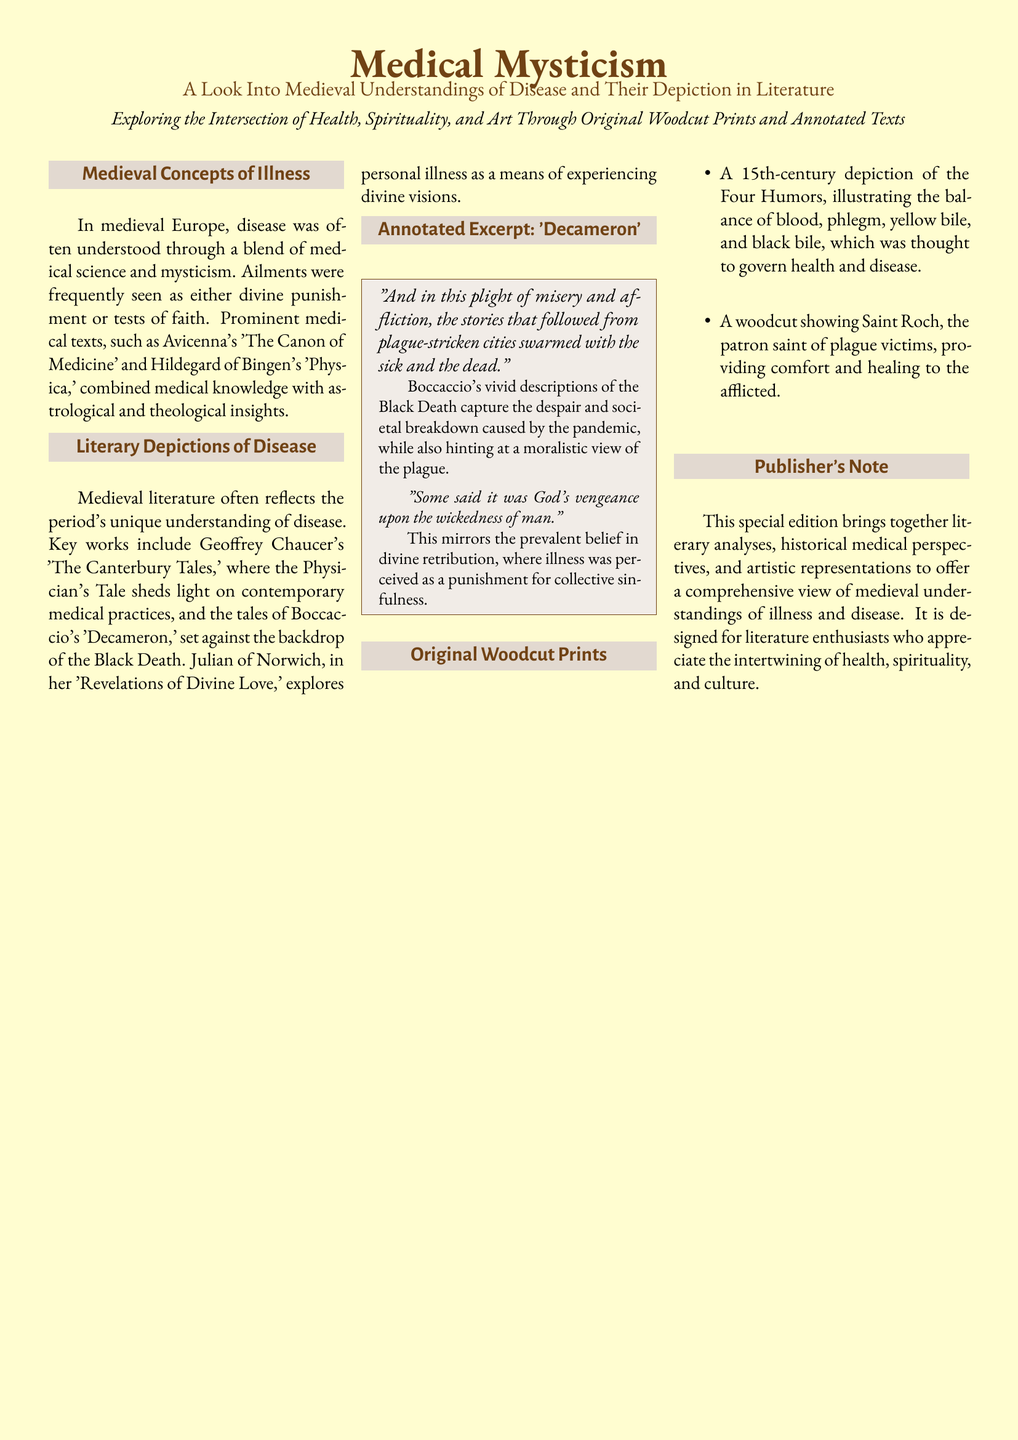What are the names of two prominent medical texts mentioned? The texts referenced in the document are used to illustrate medieval medical understanding, specifically stating Avicenna's 'The Canon of Medicine' and Hildegard of Bingen's 'Physica'.
Answer: 'The Canon of Medicine' and 'Physica' Which literary work is associated with the Physician's Tale? The document highlights Geoffrey Chaucer's 'The Canterbury Tales' as the work that contains the Physician's Tale, providing insight into contemporary medical practices.
Answer: 'The Canterbury Tales' What century is the woodcut of the Four Humors from? The document specifies the time period of the woodcut depicting the Four Humors, stating it is from the 15th century.
Answer: 15th century What does the quote in Boccaccio's excerpt reference regarding God? The excerpt from the 'Decameron' discusses a specific belief regarding divine retribution, indicating that some believed it was God's vengeance upon human wickedness.
Answer: God's vengeance What is the focus of the publisher's note? The publisher's note in the document outlines the overall theme and purpose of the publication, emphasizing the integration of literary, historical, and artistic perspectives on medieval illness and disease.
Answer: Comprehensive view of medieval understandings How does the document describe the condition in plague-stricken cities? The document conveys the severity of the situation during the plague using Boccaccio's text, which details the rampant sickness and despair in affected areas.
Answer: Misery and affliction 